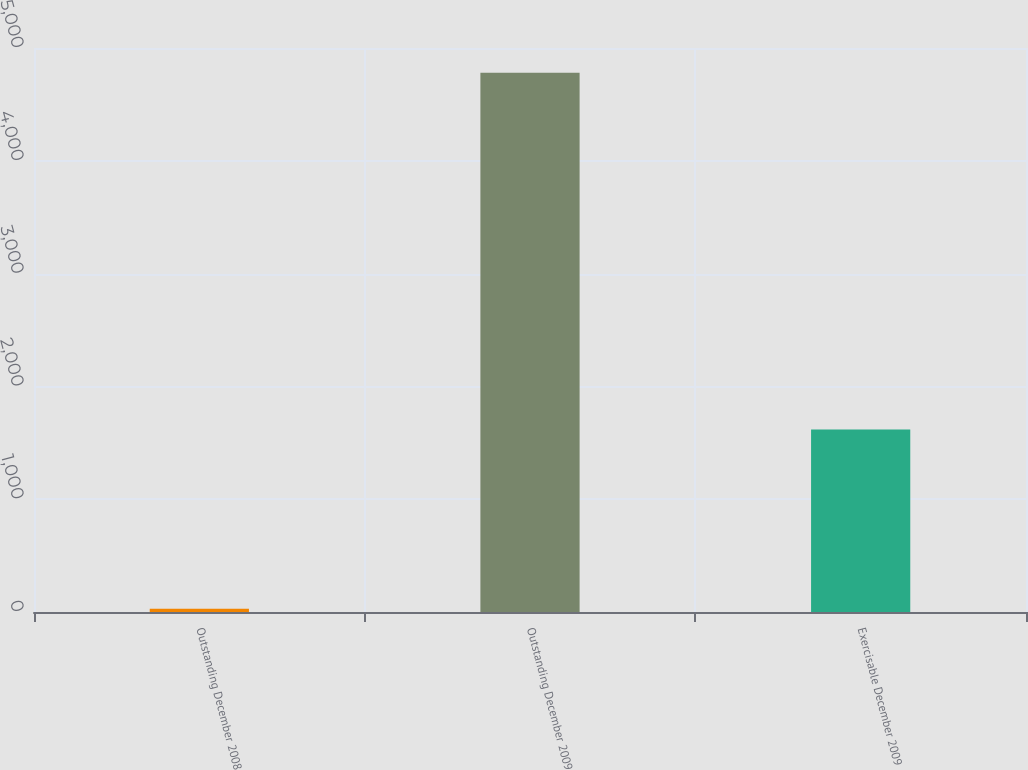Convert chart to OTSL. <chart><loc_0><loc_0><loc_500><loc_500><bar_chart><fcel>Outstanding December 2008<fcel>Outstanding December 2009<fcel>Exercisable December 2009<nl><fcel>29<fcel>4781<fcel>1618<nl></chart> 